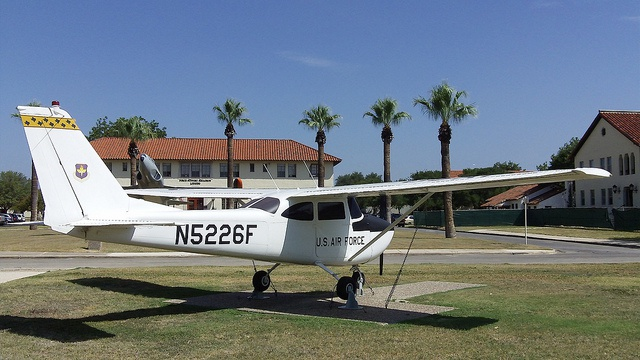Describe the objects in this image and their specific colors. I can see a airplane in gray, white, black, and darkgray tones in this image. 